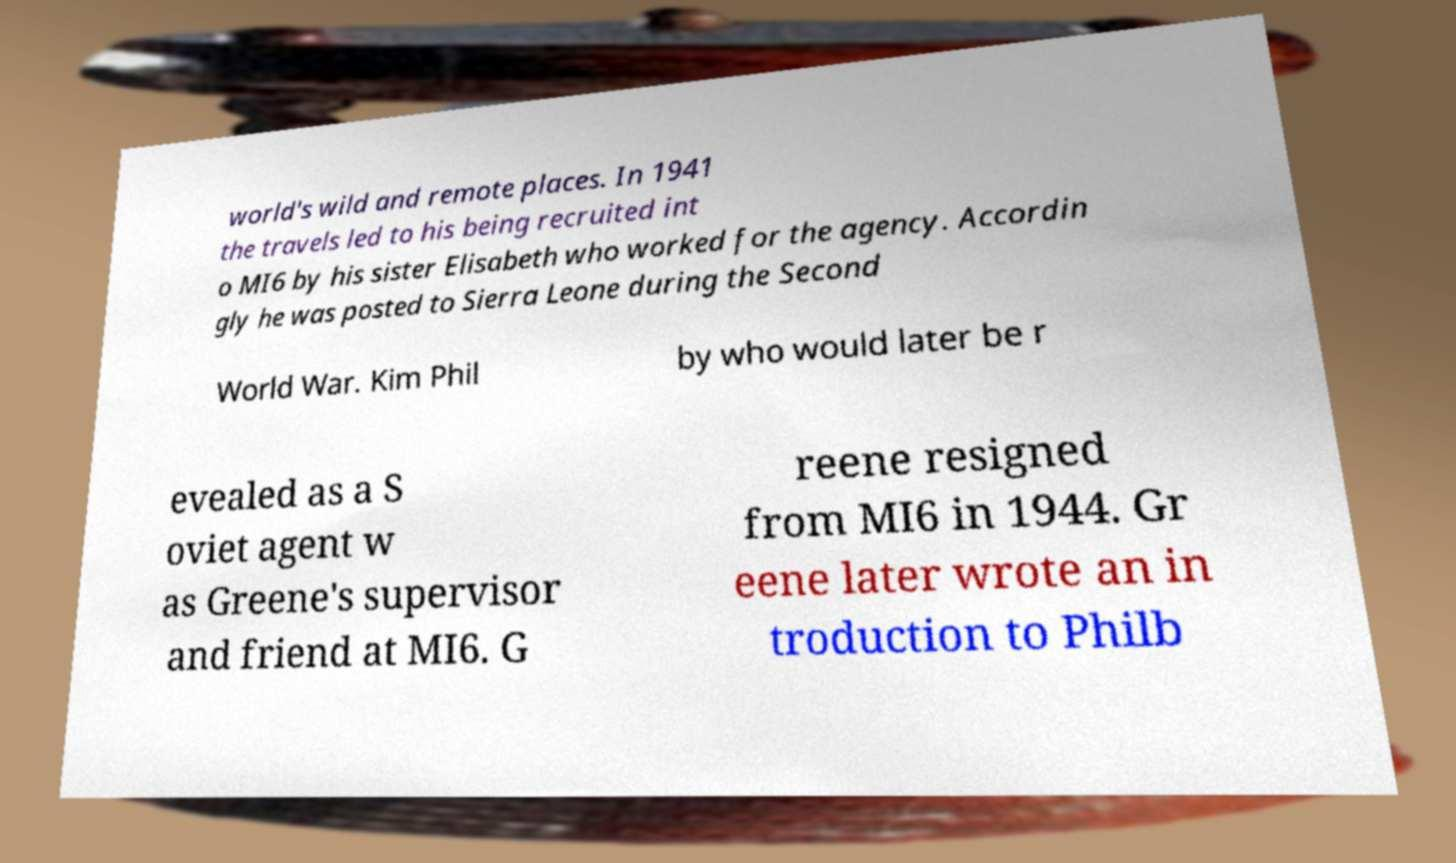Can you accurately transcribe the text from the provided image for me? world's wild and remote places. In 1941 the travels led to his being recruited int o MI6 by his sister Elisabeth who worked for the agency. Accordin gly he was posted to Sierra Leone during the Second World War. Kim Phil by who would later be r evealed as a S oviet agent w as Greene's supervisor and friend at MI6. G reene resigned from MI6 in 1944. Gr eene later wrote an in troduction to Philb 